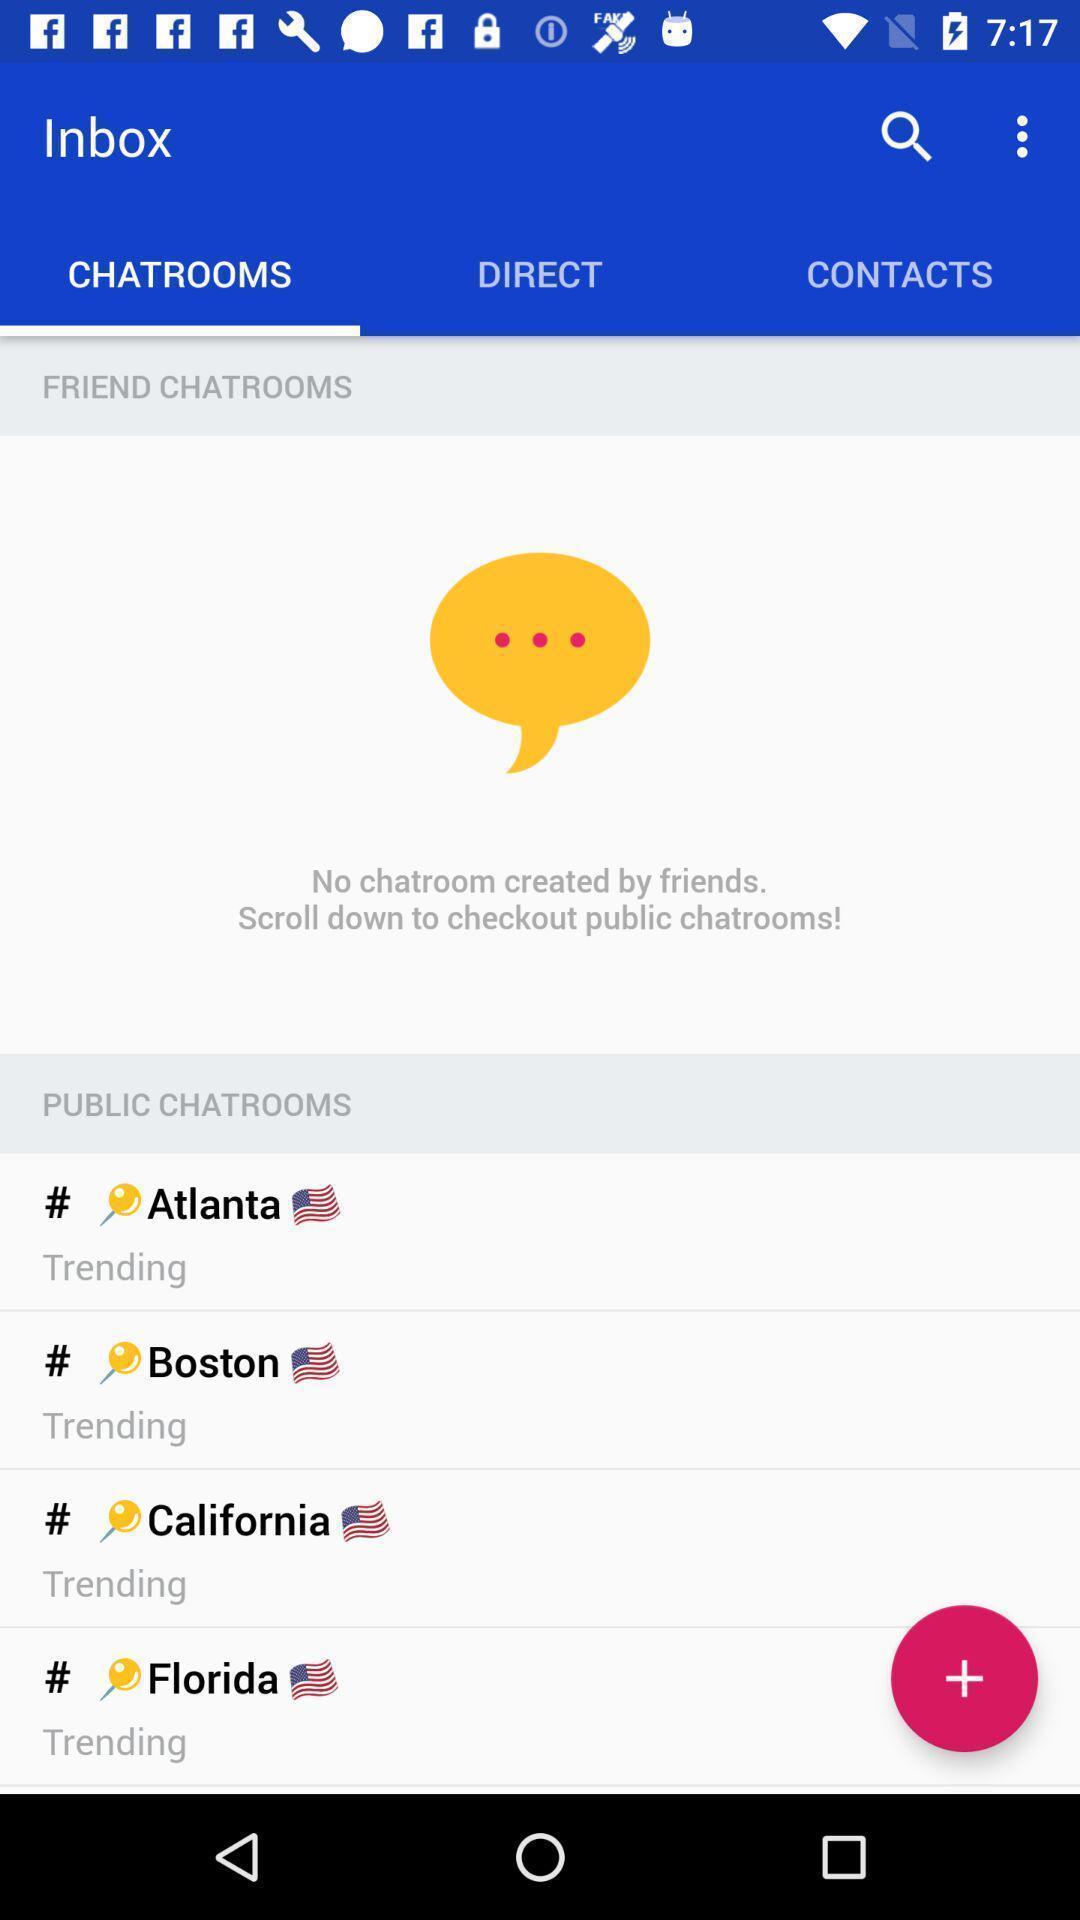Tell me what you see in this picture. Screen showing chat room page. 